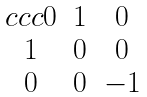<formula> <loc_0><loc_0><loc_500><loc_500>\begin{matrix} { c c c } 0 & 1 & 0 \\ 1 & 0 & 0 \\ 0 & 0 & - 1 \end{matrix}</formula> 